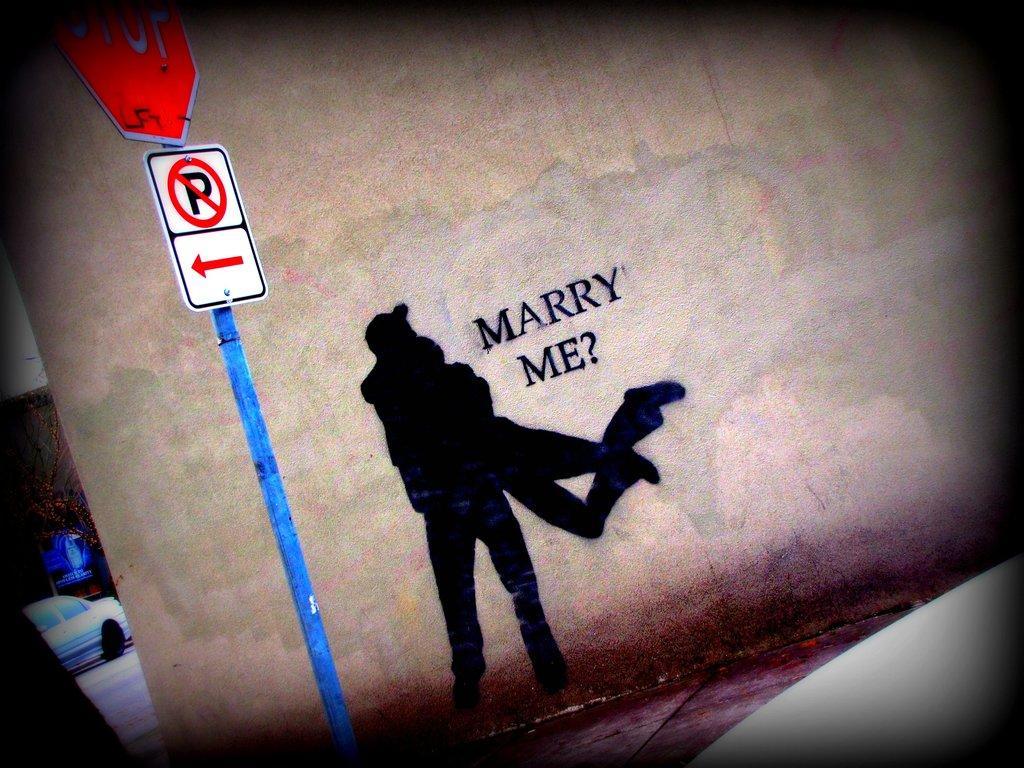Could you give a brief overview of what you see in this image? In the center of the image we can see the drawing of two persons with text on the wall. We can also see a stop sign board to the pole. On the left there is a vehicle and also the tree and road. 